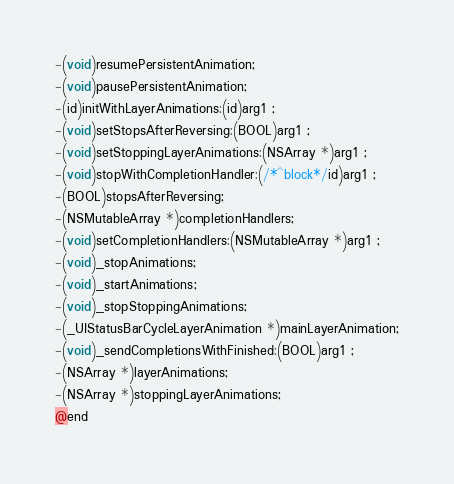Convert code to text. <code><loc_0><loc_0><loc_500><loc_500><_C_>-(void)resumePersistentAnimation;
-(void)pausePersistentAnimation;
-(id)initWithLayerAnimations:(id)arg1 ;
-(void)setStopsAfterReversing:(BOOL)arg1 ;
-(void)setStoppingLayerAnimations:(NSArray *)arg1 ;
-(void)stopWithCompletionHandler:(/*^block*/id)arg1 ;
-(BOOL)stopsAfterReversing;
-(NSMutableArray *)completionHandlers;
-(void)setCompletionHandlers:(NSMutableArray *)arg1 ;
-(void)_stopAnimations;
-(void)_startAnimations;
-(void)_stopStoppingAnimations;
-(_UIStatusBarCycleLayerAnimation *)mainLayerAnimation;
-(void)_sendCompletionsWithFinished:(BOOL)arg1 ;
-(NSArray *)layerAnimations;
-(NSArray *)stoppingLayerAnimations;
@end

</code> 